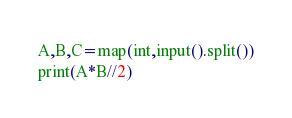Convert code to text. <code><loc_0><loc_0><loc_500><loc_500><_Python_>A,B,C=map(int,input().split())
print(A*B//2)</code> 